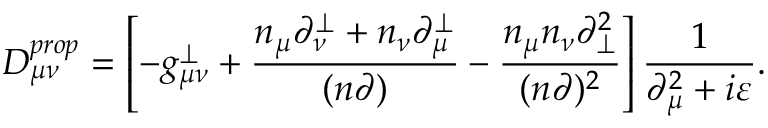Convert formula to latex. <formula><loc_0><loc_0><loc_500><loc_500>D _ { \mu \nu } ^ { p r o p } = \left [ - g _ { \mu \nu } ^ { \perp } + \frac { n _ { \mu } \partial _ { \nu } ^ { \perp } + n _ { \nu } \partial _ { \mu } ^ { \perp } } { ( n \partial ) } - \frac { n _ { \mu } n _ { \nu } \partial _ { \perp } ^ { 2 } } { ( n \partial ) ^ { 2 } } \right ] \frac { 1 } { \partial _ { \mu } ^ { 2 } + i \varepsilon } .</formula> 